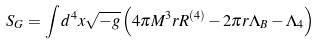Convert formula to latex. <formula><loc_0><loc_0><loc_500><loc_500>S _ { G } = \int d ^ { 4 } x \sqrt { - g } \left ( 4 \pi M ^ { 3 } r R ^ { \left ( 4 \right ) } - 2 \pi r \Lambda _ { B } - \Lambda _ { 4 } \right )</formula> 